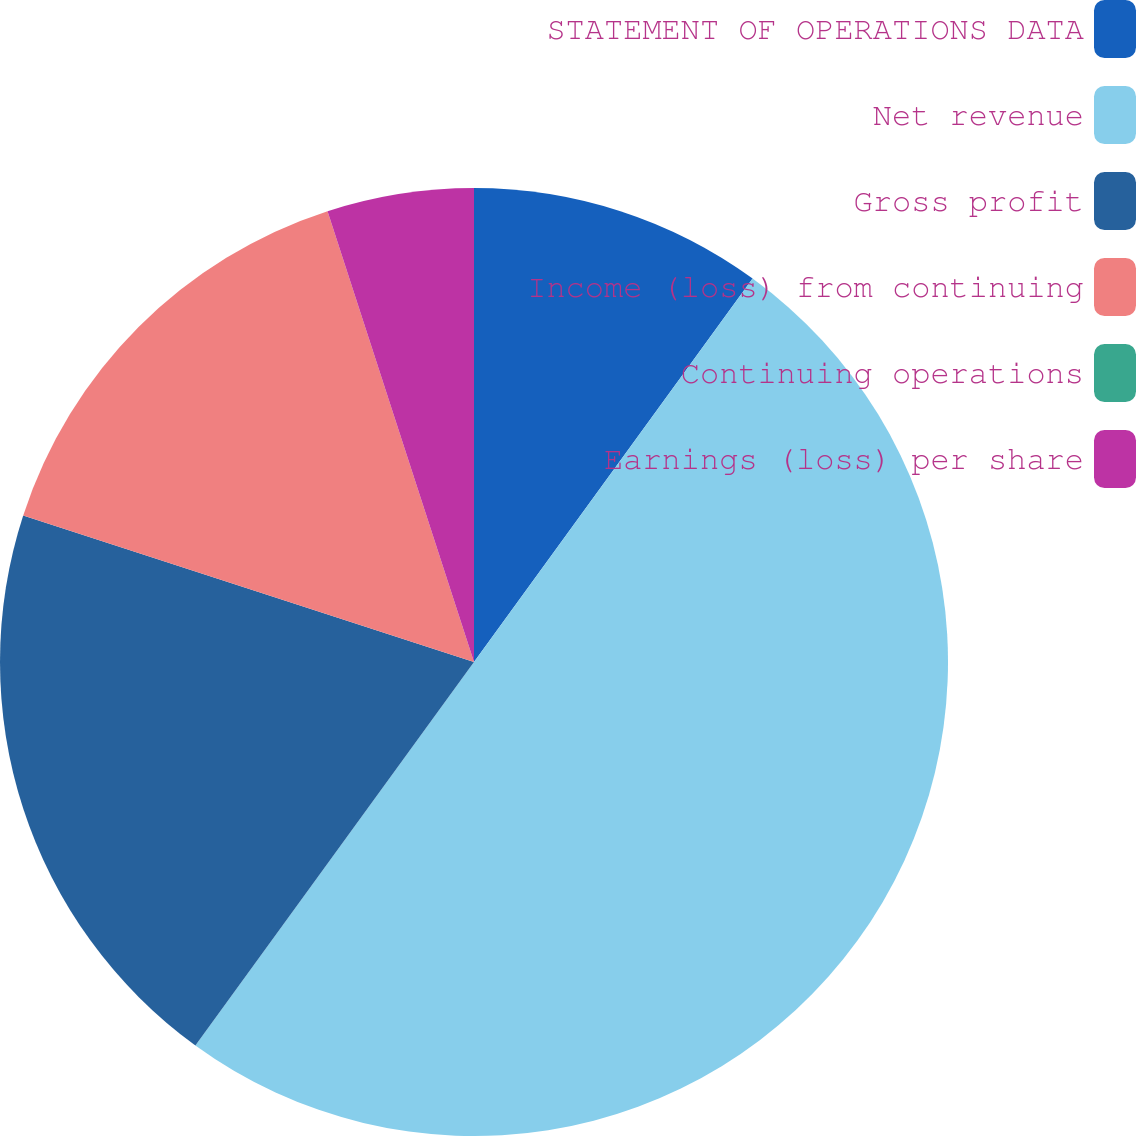<chart> <loc_0><loc_0><loc_500><loc_500><pie_chart><fcel>STATEMENT OF OPERATIONS DATA<fcel>Net revenue<fcel>Gross profit<fcel>Income (loss) from continuing<fcel>Continuing operations<fcel>Earnings (loss) per share<nl><fcel>10.0%<fcel>50.0%<fcel>20.0%<fcel>15.0%<fcel>0.0%<fcel>5.0%<nl></chart> 